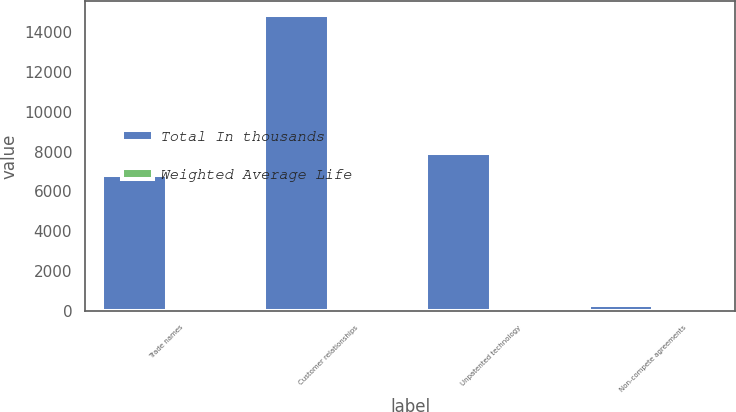Convert chart to OTSL. <chart><loc_0><loc_0><loc_500><loc_500><stacked_bar_chart><ecel><fcel>Trade names<fcel>Customer relationships<fcel>Unpatented technology<fcel>Non-compete agreements<nl><fcel>Total In thousands<fcel>6802<fcel>14832<fcel>7951<fcel>276<nl><fcel>Weighted Average Life<fcel>13<fcel>8<fcel>14<fcel>3<nl></chart> 